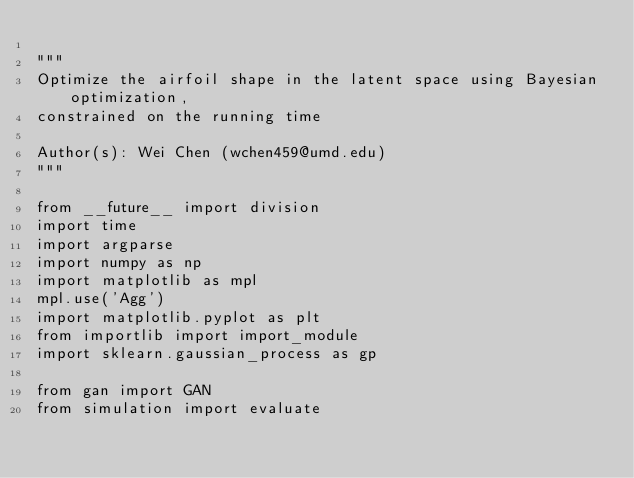<code> <loc_0><loc_0><loc_500><loc_500><_Python_>
"""
Optimize the airfoil shape in the latent space using Bayesian optimization, 
constrained on the running time

Author(s): Wei Chen (wchen459@umd.edu)
"""

from __future__ import division
import time
import argparse
import numpy as np
import matplotlib as mpl
mpl.use('Agg')
import matplotlib.pyplot as plt
from importlib import import_module
import sklearn.gaussian_process as gp

from gan import GAN
from simulation import evaluate</code> 